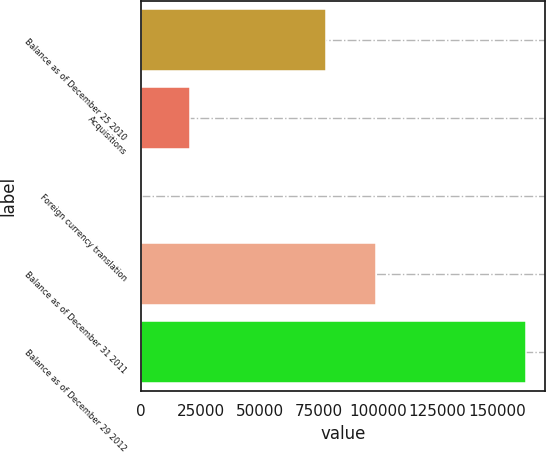Convert chart. <chart><loc_0><loc_0><loc_500><loc_500><bar_chart><fcel>Balance as of December 25 2010<fcel>Acquisitions<fcel>Foreign currency translation<fcel>Balance as of December 31 2011<fcel>Balance as of December 29 2012<nl><fcel>77969<fcel>20630<fcel>261<fcel>98860<fcel>162124<nl></chart> 